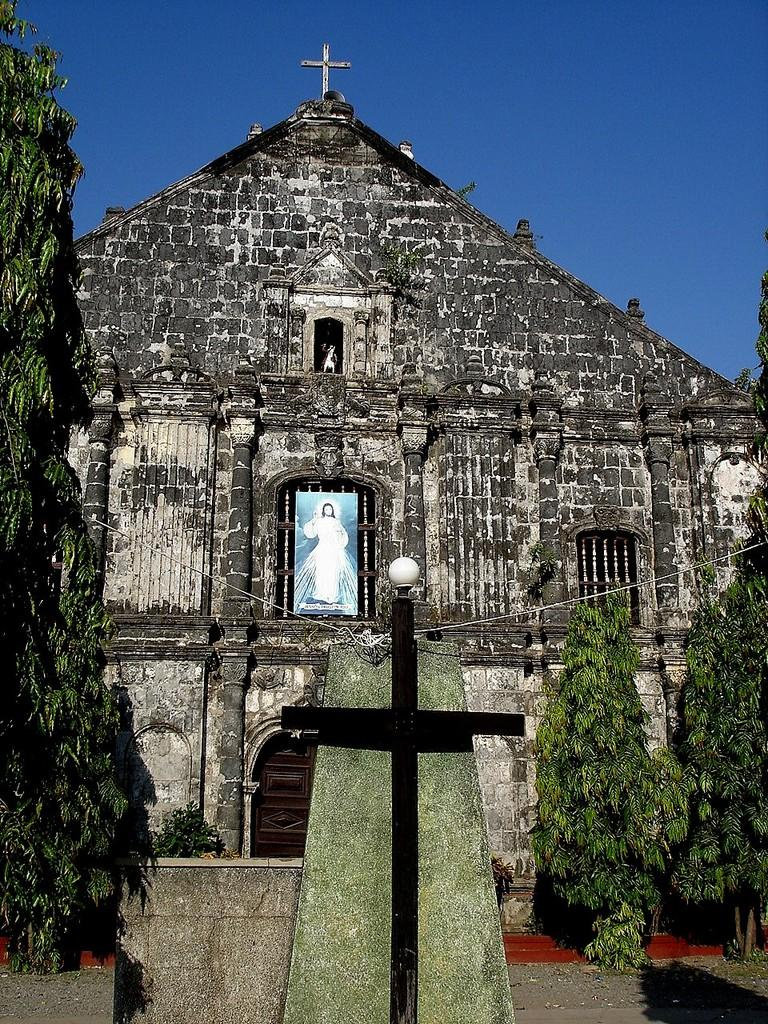What type of natural elements can be seen in the image? There are trees in the image. What type of man-made structure is present in the image? There is a building in the image. What other objects can be seen in the image besides trees and the building? There are other objects in the image. What religious symbol is present in the image? There is a photo of Jesus on the wall. What is visible in the background of the image? The sky is visible in the background of the image. What type of wall can be seen bursting in the image? There is no wall bursting in the image. Whose hand can be seen reaching out from the building in the image? There are no hands visible in the image. 